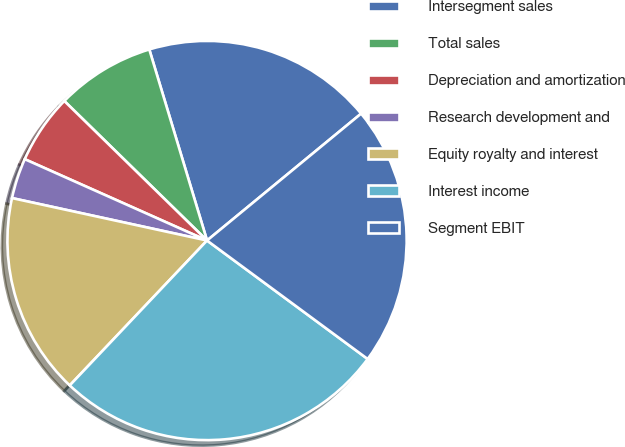<chart> <loc_0><loc_0><loc_500><loc_500><pie_chart><fcel>Intersegment sales<fcel>Total sales<fcel>Depreciation and amortization<fcel>Research development and<fcel>Equity royalty and interest<fcel>Interest income<fcel>Segment EBIT<nl><fcel>18.71%<fcel>8.01%<fcel>5.64%<fcel>3.27%<fcel>16.34%<fcel>26.96%<fcel>21.08%<nl></chart> 